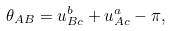Convert formula to latex. <formula><loc_0><loc_0><loc_500><loc_500>\theta _ { A B } = u _ { B c } ^ { b } + u _ { A c } ^ { a } - \pi ,</formula> 